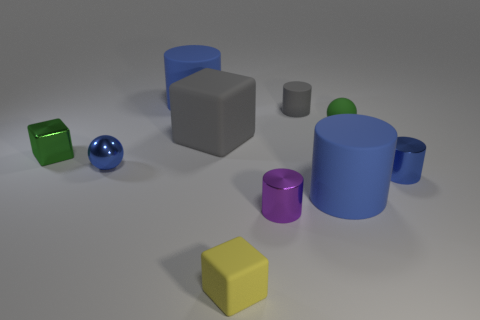Does the sphere on the left side of the green ball have the same color as the large rubber block right of the small blue ball?
Give a very brief answer. No. There is a shiny cylinder that is the same size as the purple metal thing; what color is it?
Your answer should be very brief. Blue. Are there any shiny cubes that have the same color as the tiny rubber ball?
Keep it short and to the point. Yes. There is a yellow matte cube in front of the shiny block; is its size the same as the small green matte ball?
Offer a terse response. Yes. Are there the same number of small rubber spheres on the left side of the tiny green matte object and large cubes?
Your answer should be compact. No. How many things are blue rubber objects behind the tiny blue sphere or tiny objects?
Ensure brevity in your answer.  8. The matte thing that is both in front of the green metallic thing and behind the yellow thing has what shape?
Your response must be concise. Cylinder. What number of objects are either gray things that are behind the rubber ball or cylinders to the left of the tiny rubber block?
Offer a very short reply. 2. What number of other things are there of the same size as the green metallic thing?
Offer a very short reply. 6. There is a shiny object that is to the right of the green sphere; is it the same color as the small rubber block?
Ensure brevity in your answer.  No. 